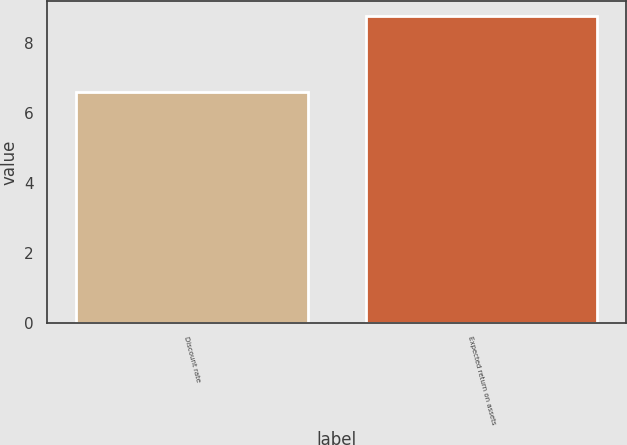<chart> <loc_0><loc_0><loc_500><loc_500><bar_chart><fcel>Discount rate<fcel>Expected return on assets<nl><fcel>6.58<fcel>8.75<nl></chart> 